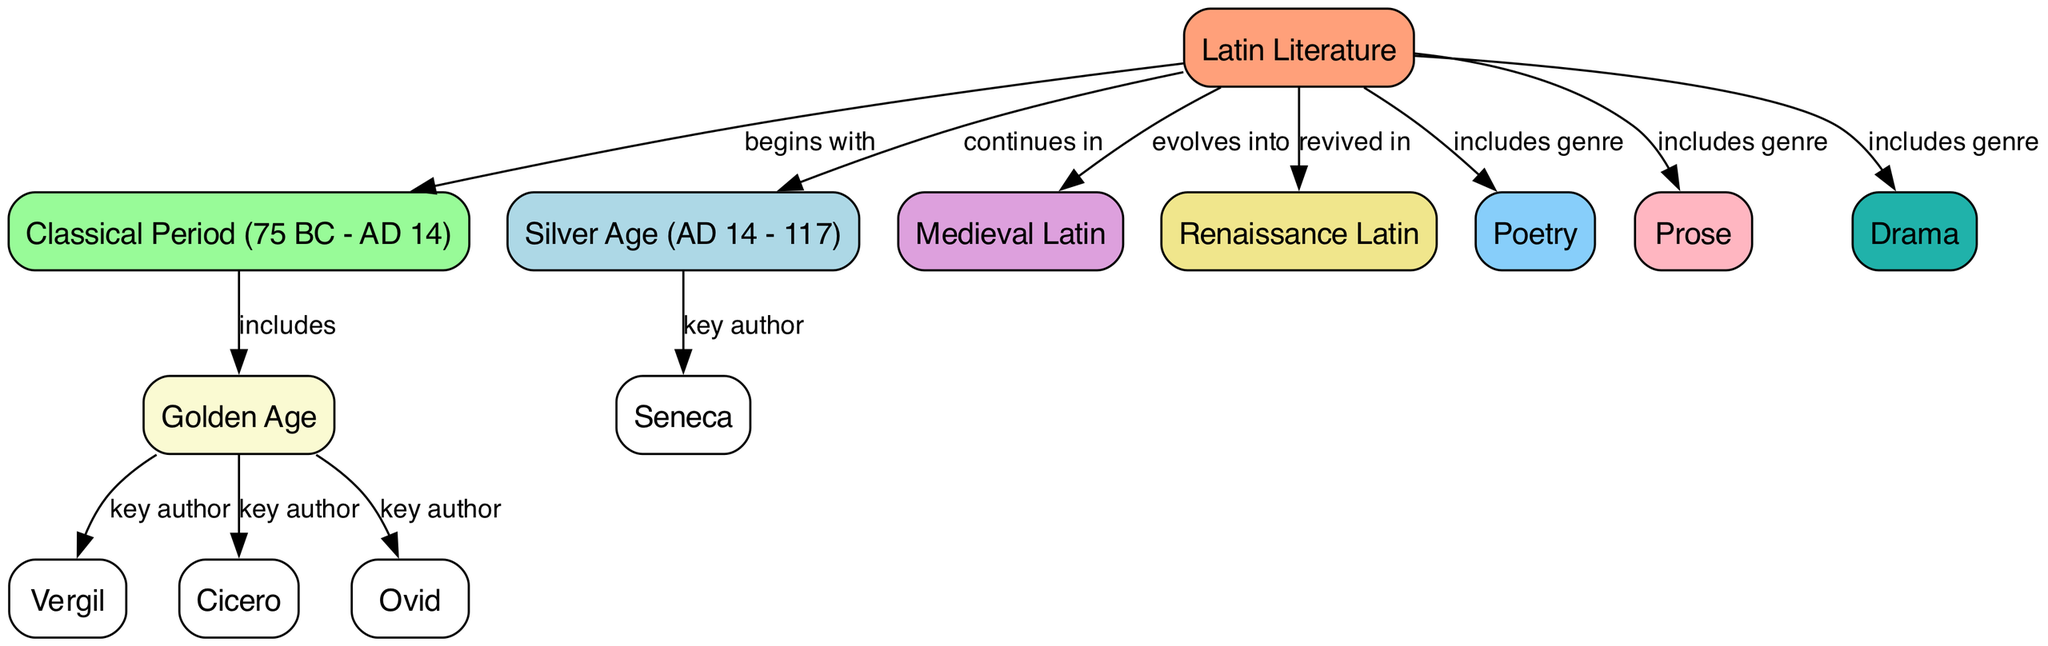What is the starting point of Latin literature? The diagram indicates that Latin literature begins with the classical period, which is specifically marked as (75 BC - AD 14). This is the foundational node leading to other developments.
Answer: Classical Period (75 BC - AD 14) Which genres are included in Latin literature? The diagram specifies that Latin literature includes the genres of poetry, prose, and drama. These are connected directly to the main node of Latin literature.
Answer: Poetry, Prose, Drama How many key authors are listed in the Golden Age? The diagram shows three key authors that are associated with the Golden Age: Vergil, Cicero, and Ovid. This information is depicted through direct connections to the Golden Age node.
Answer: 3 Which era does Latin literature evolve into after the classical period? According to the diagram, Latin literature evolves into Medieval Latin following the classical period, signifying a progression into another significant phase of literature.
Answer: Medieval Latin What period continues after the Golden Age of Latin literature? The diagram illustrates that Latin literature continues into the Silver Age, indicating a chronological flow from one literary era to another.
Answer: Silver Age (AD 14 - 117) What are the primary characteristics of the Silver Age? The Silver Age is primarily characterized by the prominent author Seneca, which is specifically noted in the diagram as a key author contributing to that period of Latin literature.
Answer: Seneca What literary period is referred to as the revival of Latin literature? The diagram presents the Renaissance Latin as the period when Latin literature underwent revival, indicating a resurgence of interest and production of Latin texts after the medieval period.
Answer: Renaissance Latin Which author is linked to the Golden Age alongside Cicero and Ovid? Vergil is the additional author directly linked with Cicero and Ovid in the Golden Age segment of the diagram, emphasizing his importance in this literary context.
Answer: Vergil 